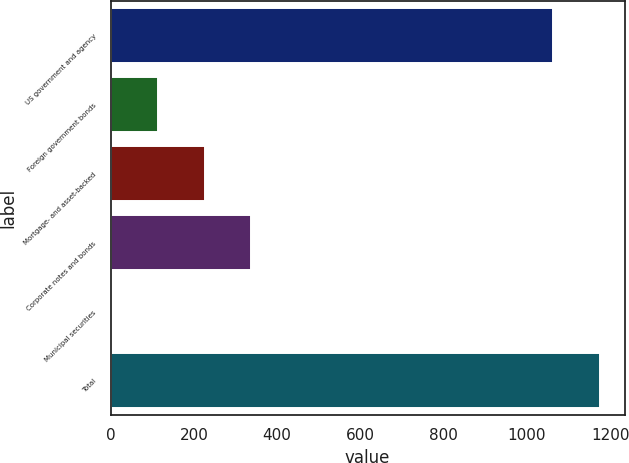<chart> <loc_0><loc_0><loc_500><loc_500><bar_chart><fcel>US government and agency<fcel>Foreign government bonds<fcel>Mortgage- and asset-backed<fcel>Corporate notes and bonds<fcel>Municipal securities<fcel>Total<nl><fcel>1064<fcel>113.3<fcel>225.6<fcel>337.9<fcel>1<fcel>1176.3<nl></chart> 